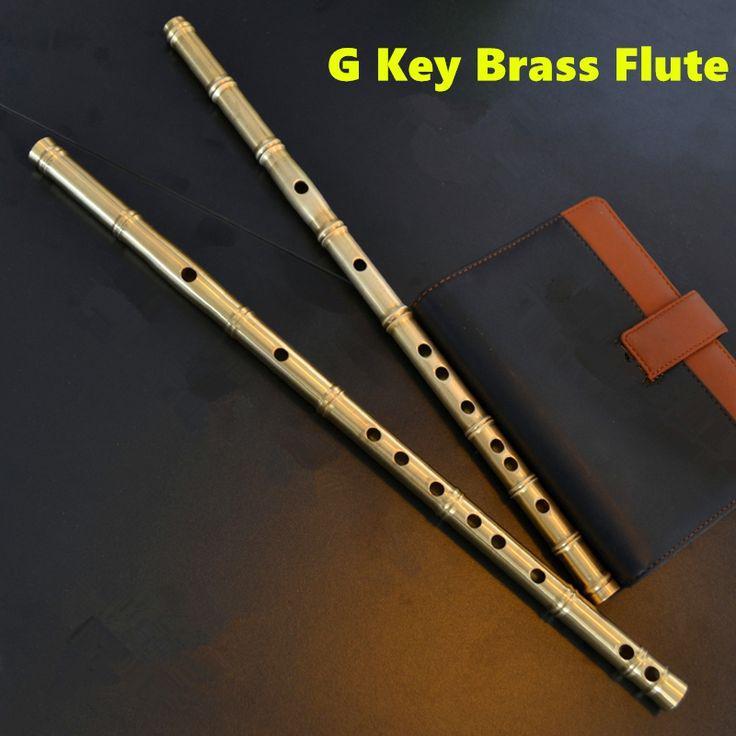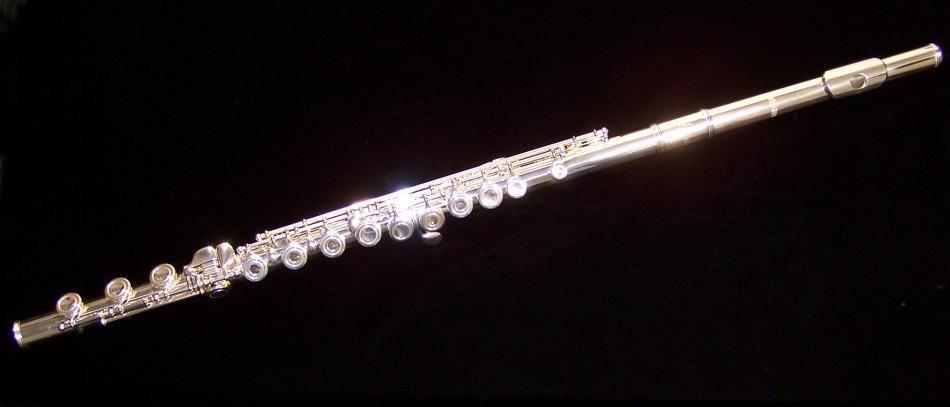The first image is the image on the left, the second image is the image on the right. For the images displayed, is the sentence "One image shows at least four flutes arranged in a row but not perfectly parallel to one another." factually correct? Answer yes or no. No. The first image is the image on the left, the second image is the image on the right. Examine the images to the left and right. Is the description "There are more than three instruments in at least one of the images." accurate? Answer yes or no. No. 